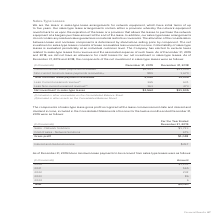According to Adtran's financial document, Where was current minimum lease payments receivable included in the Consolidated Balance Sheet? According to the financial document, other receivables. The relevant text states: "(1) Included in other receivables on the Consolidated Balance Sheet. (2) Included in other assets on the Consolidated Balance Sheet...." Also, Where was non-current minimum lease payments receivable included in the Consolidated Balance Sheet? According to the financial document, other assets. The relevant text states: "n the Consolidated Balance Sheet. (2) Included in other assets on the Consolidated Balance Sheet...." Also, What was the non-current minimum lease payments receivable in 2019? According to the financial document, $1,201 (in thousands). The relevant text states: "Current minimum lease payments receivable (1) $1,201 $11,339..." Also, can you calculate: What was the difference in total minimum lease payments receivables between 2018 and 2019? Based on the calculation: 2,090-13,009, the result is -10919 (in thousands). This is based on the information: "Total minimum lease payments receivable 2,090 13,009 Total minimum lease payments receivable 2,090 13,009..." The key data points involved are: 13,009, 2,090. Also, can you calculate: What was the change in Non-current minimum lease payments receivable between 2018 and 2019? Based on the calculation: 889-1,670, the result is -781 (in thousands). This is based on the information: "current minimum lease payments receivable (2) 889 1,670 Non-current minimum lease payments receivable (2) 889 1,670..." The key data points involved are: 1,670, 889. Also, can you calculate: What was the percentage change in net investment in sales-type leases between 2018 and 2019? To answer this question, I need to perform calculations using the financial data. The calculation is: ($1,562-$11,905)/$11,905, which equals -86.88 (percentage). This is based on the information: "Net investment in sales-type leases $1,562 $11,905 Net investment in sales-type leases $1,562 $11,905..." The key data points involved are: 1,562, 11,905. 